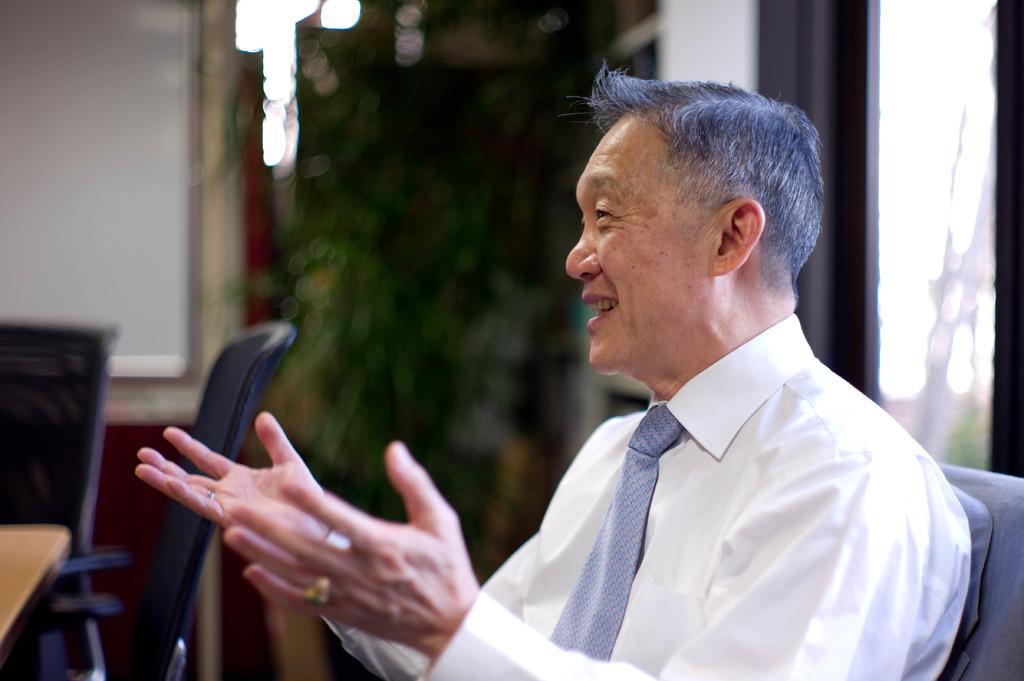Please provide a concise description of this image. In this picture we can see a man wearing a white colour shirt and a tie , he is talking. Here we can see empty chairs and a tree. 